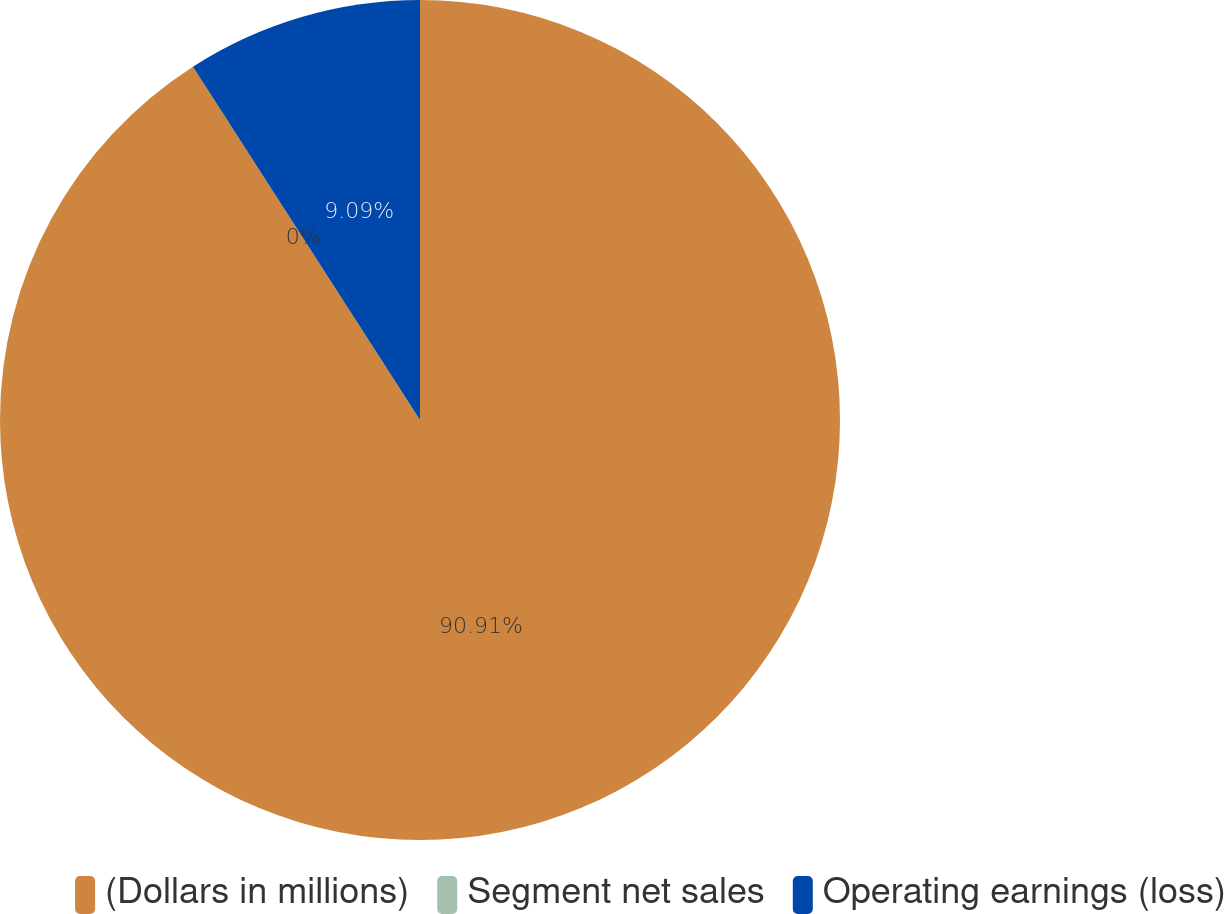Convert chart to OTSL. <chart><loc_0><loc_0><loc_500><loc_500><pie_chart><fcel>(Dollars in millions)<fcel>Segment net sales<fcel>Operating earnings (loss)<nl><fcel>90.91%<fcel>0.0%<fcel>9.09%<nl></chart> 